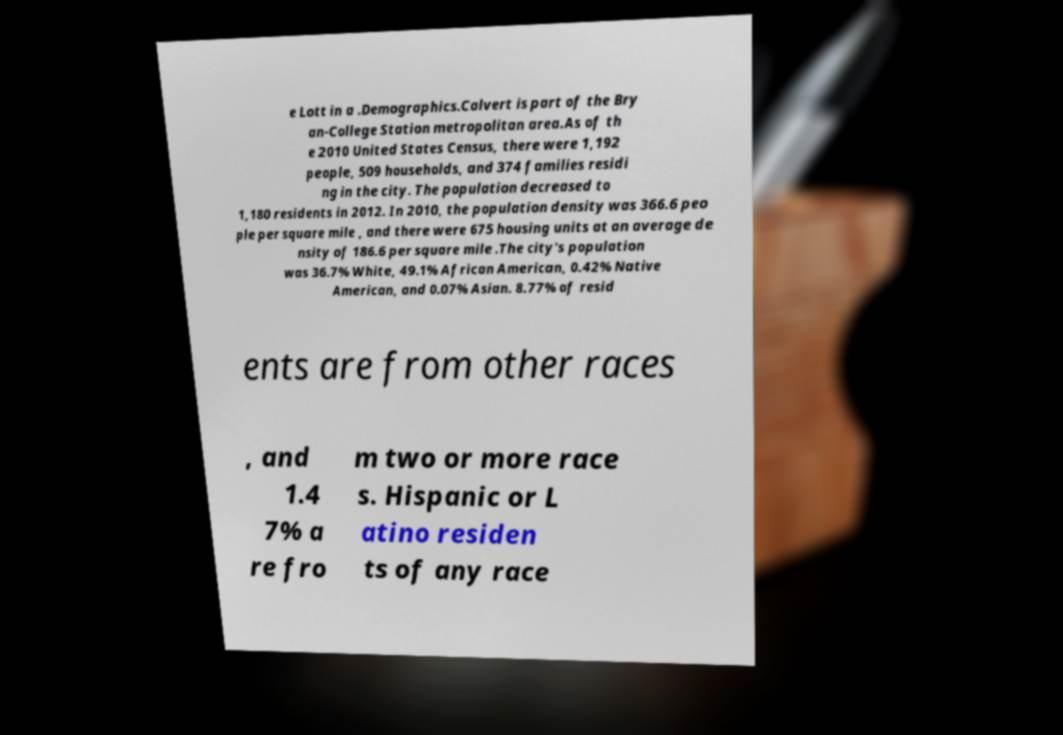There's text embedded in this image that I need extracted. Can you transcribe it verbatim? e Lott in a .Demographics.Calvert is part of the Bry an-College Station metropolitan area.As of th e 2010 United States Census, there were 1,192 people, 509 households, and 374 families residi ng in the city. The population decreased to 1,180 residents in 2012. In 2010, the population density was 366.6 peo ple per square mile , and there were 675 housing units at an average de nsity of 186.6 per square mile .The city's population was 36.7% White, 49.1% African American, 0.42% Native American, and 0.07% Asian. 8.77% of resid ents are from other races , and 1.4 7% a re fro m two or more race s. Hispanic or L atino residen ts of any race 